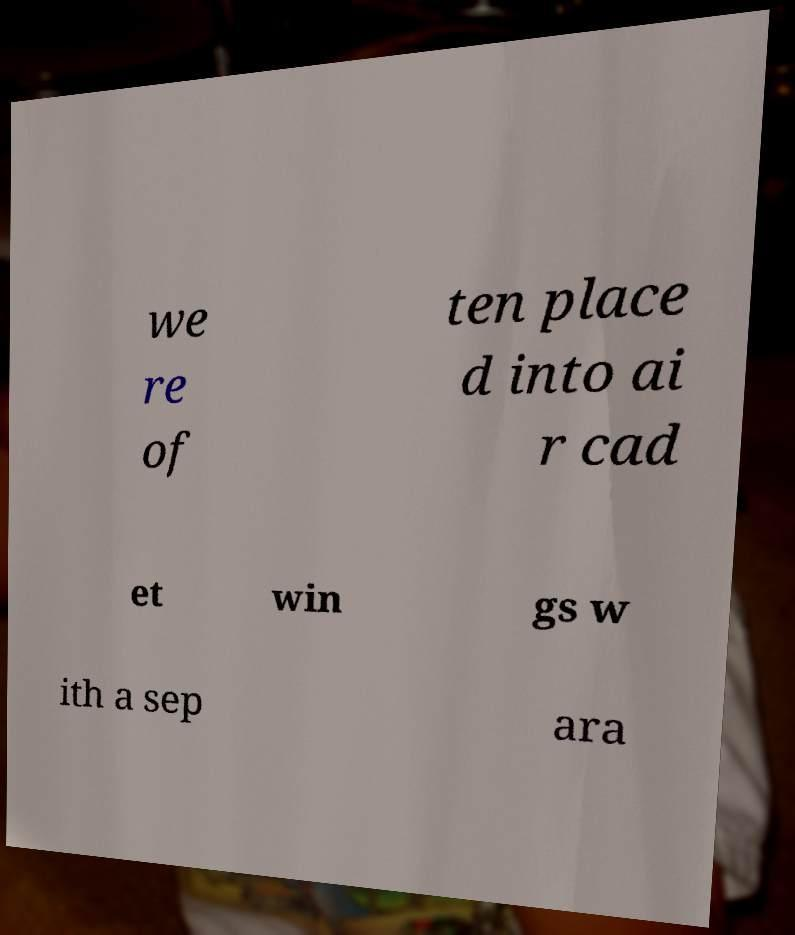There's text embedded in this image that I need extracted. Can you transcribe it verbatim? we re of ten place d into ai r cad et win gs w ith a sep ara 